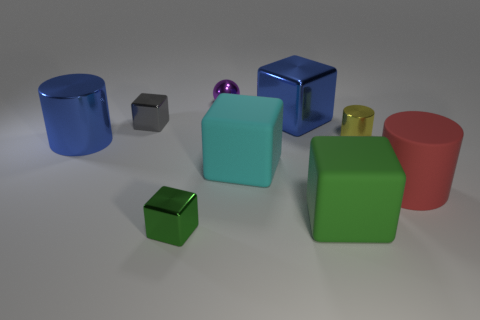Add 1 big brown rubber cylinders. How many objects exist? 10 Subtract all small blocks. How many blocks are left? 3 Subtract all yellow balls. How many green blocks are left? 2 Subtract 1 cylinders. How many cylinders are left? 2 Subtract all cyan cubes. How many cubes are left? 4 Subtract all cylinders. How many objects are left? 6 Add 8 big red objects. How many big red objects exist? 9 Subtract 1 blue cylinders. How many objects are left? 8 Subtract all purple cylinders. Subtract all yellow cubes. How many cylinders are left? 3 Subtract all big shiny things. Subtract all tiny blocks. How many objects are left? 5 